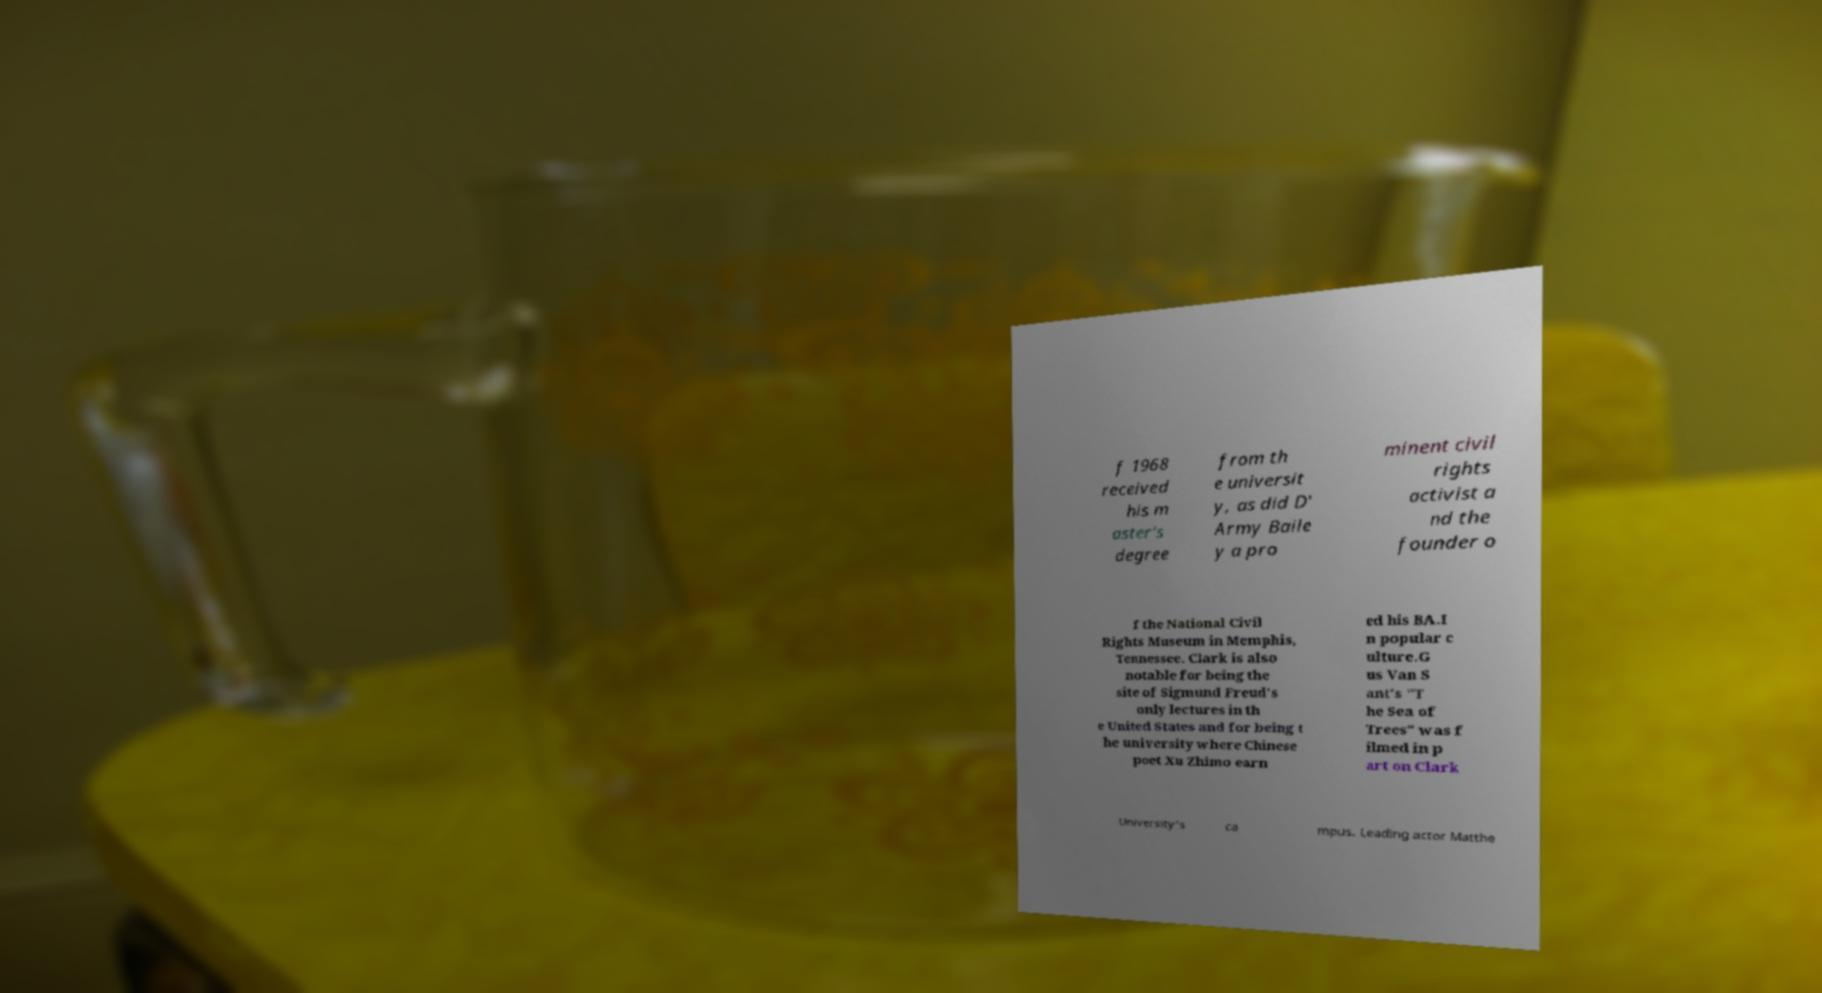I need the written content from this picture converted into text. Can you do that? f 1968 received his m aster's degree from th e universit y, as did D' Army Baile y a pro minent civil rights activist a nd the founder o f the National Civil Rights Museum in Memphis, Tennessee. Clark is also notable for being the site of Sigmund Freud's only lectures in th e United States and for being t he university where Chinese poet Xu Zhimo earn ed his BA.I n popular c ulture.G us Van S ant's "T he Sea of Trees" was f ilmed in p art on Clark University's ca mpus. Leading actor Matthe 